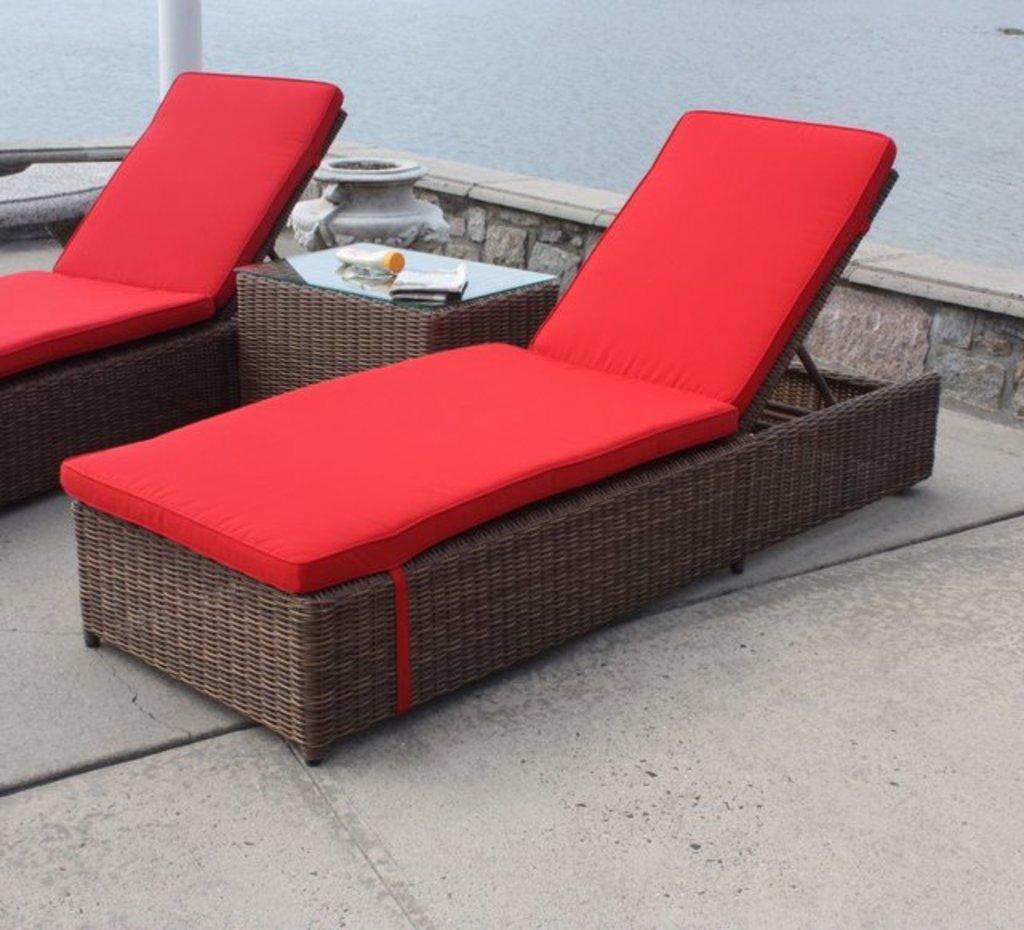Can you describe this image briefly? In this picture we can see few sun loungers, and we can find few things on the table, in the background we can see water. 